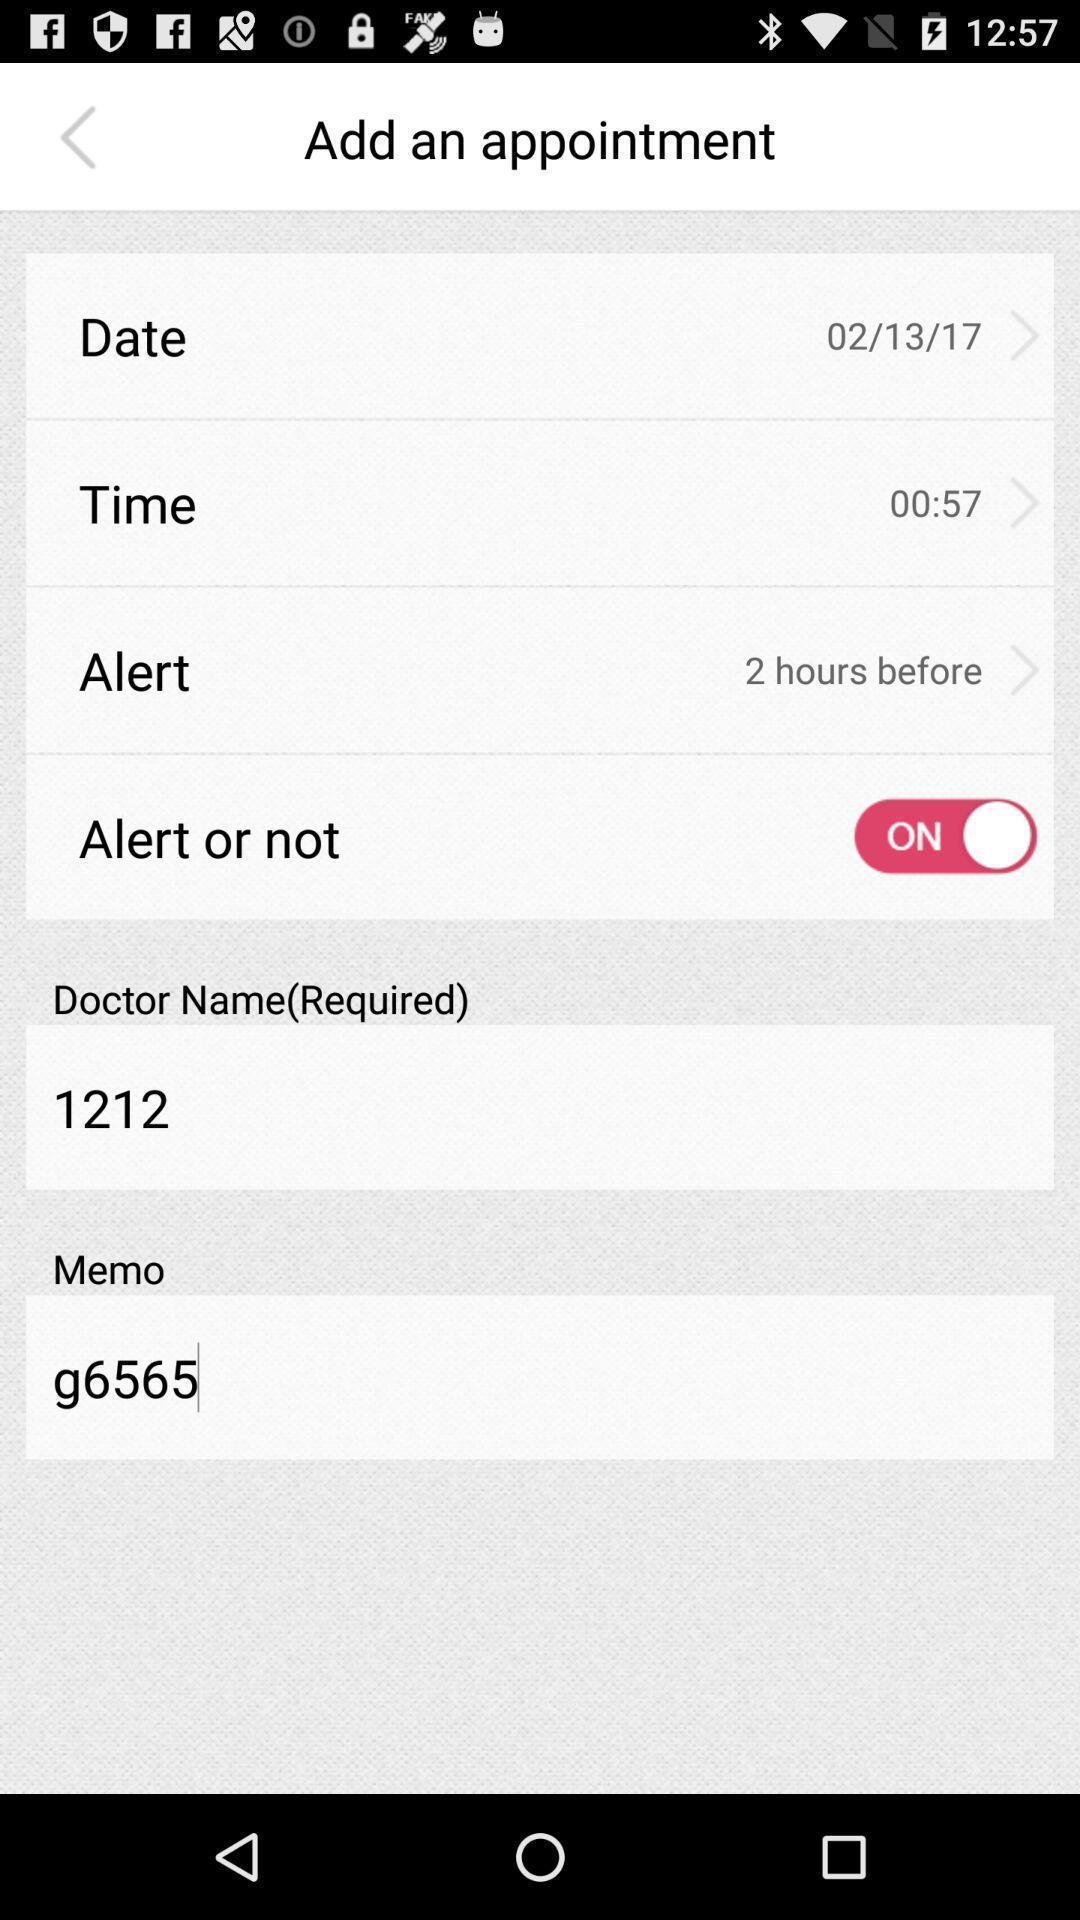Summarize the main components in this picture. Showing add appointment page in a health app. 